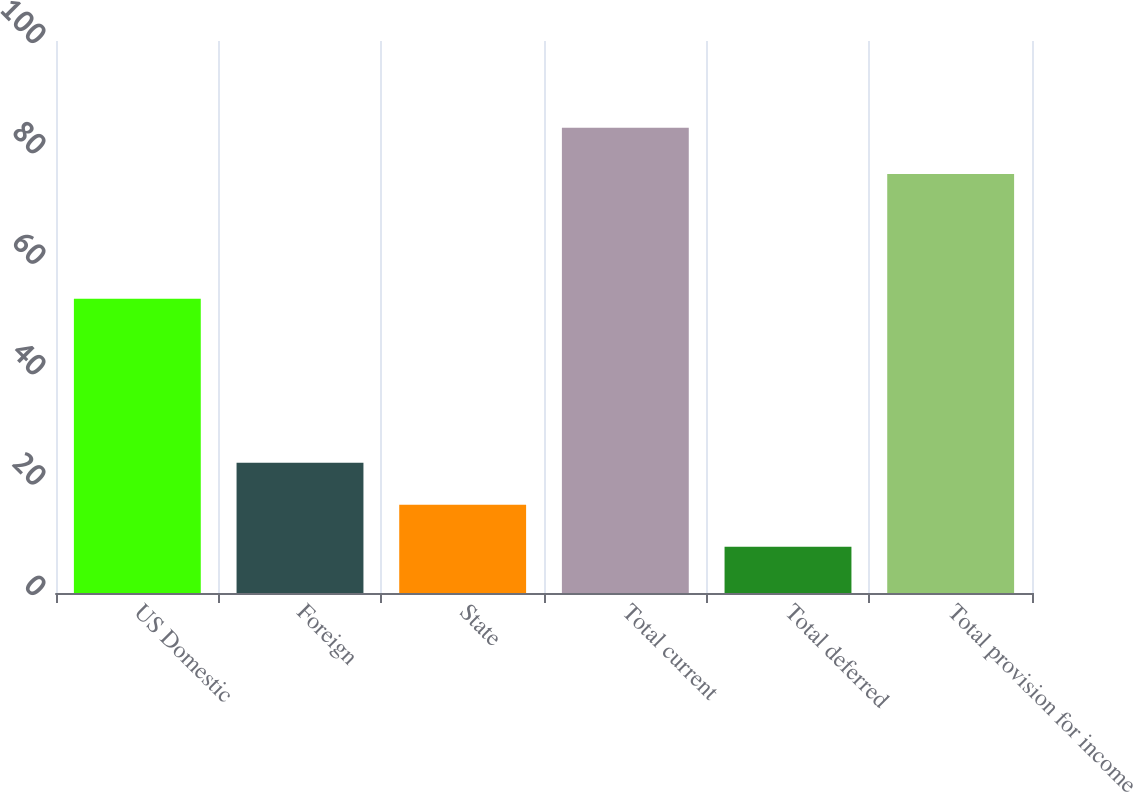Convert chart. <chart><loc_0><loc_0><loc_500><loc_500><bar_chart><fcel>US Domestic<fcel>Foreign<fcel>State<fcel>Total current<fcel>Total deferred<fcel>Total provision for income<nl><fcel>53.3<fcel>23.58<fcel>15.99<fcel>84.3<fcel>8.4<fcel>75.9<nl></chart> 